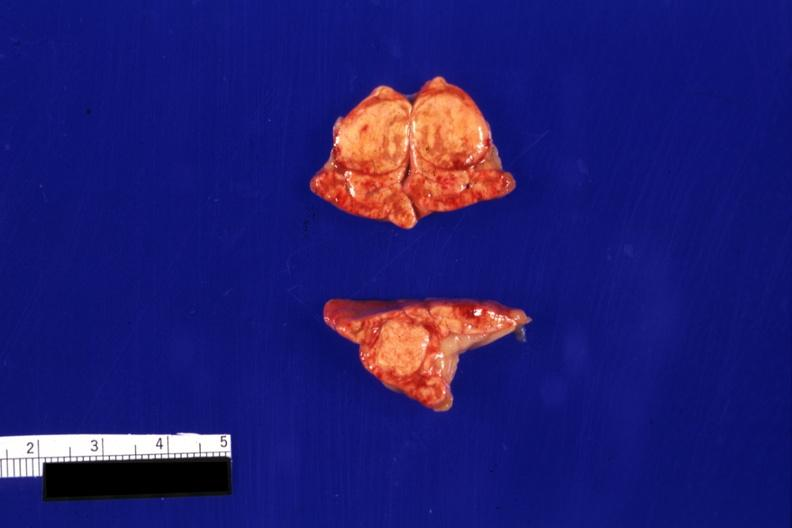does carcinomatosis show typical so-called cortical adenomas?
Answer the question using a single word or phrase. No 